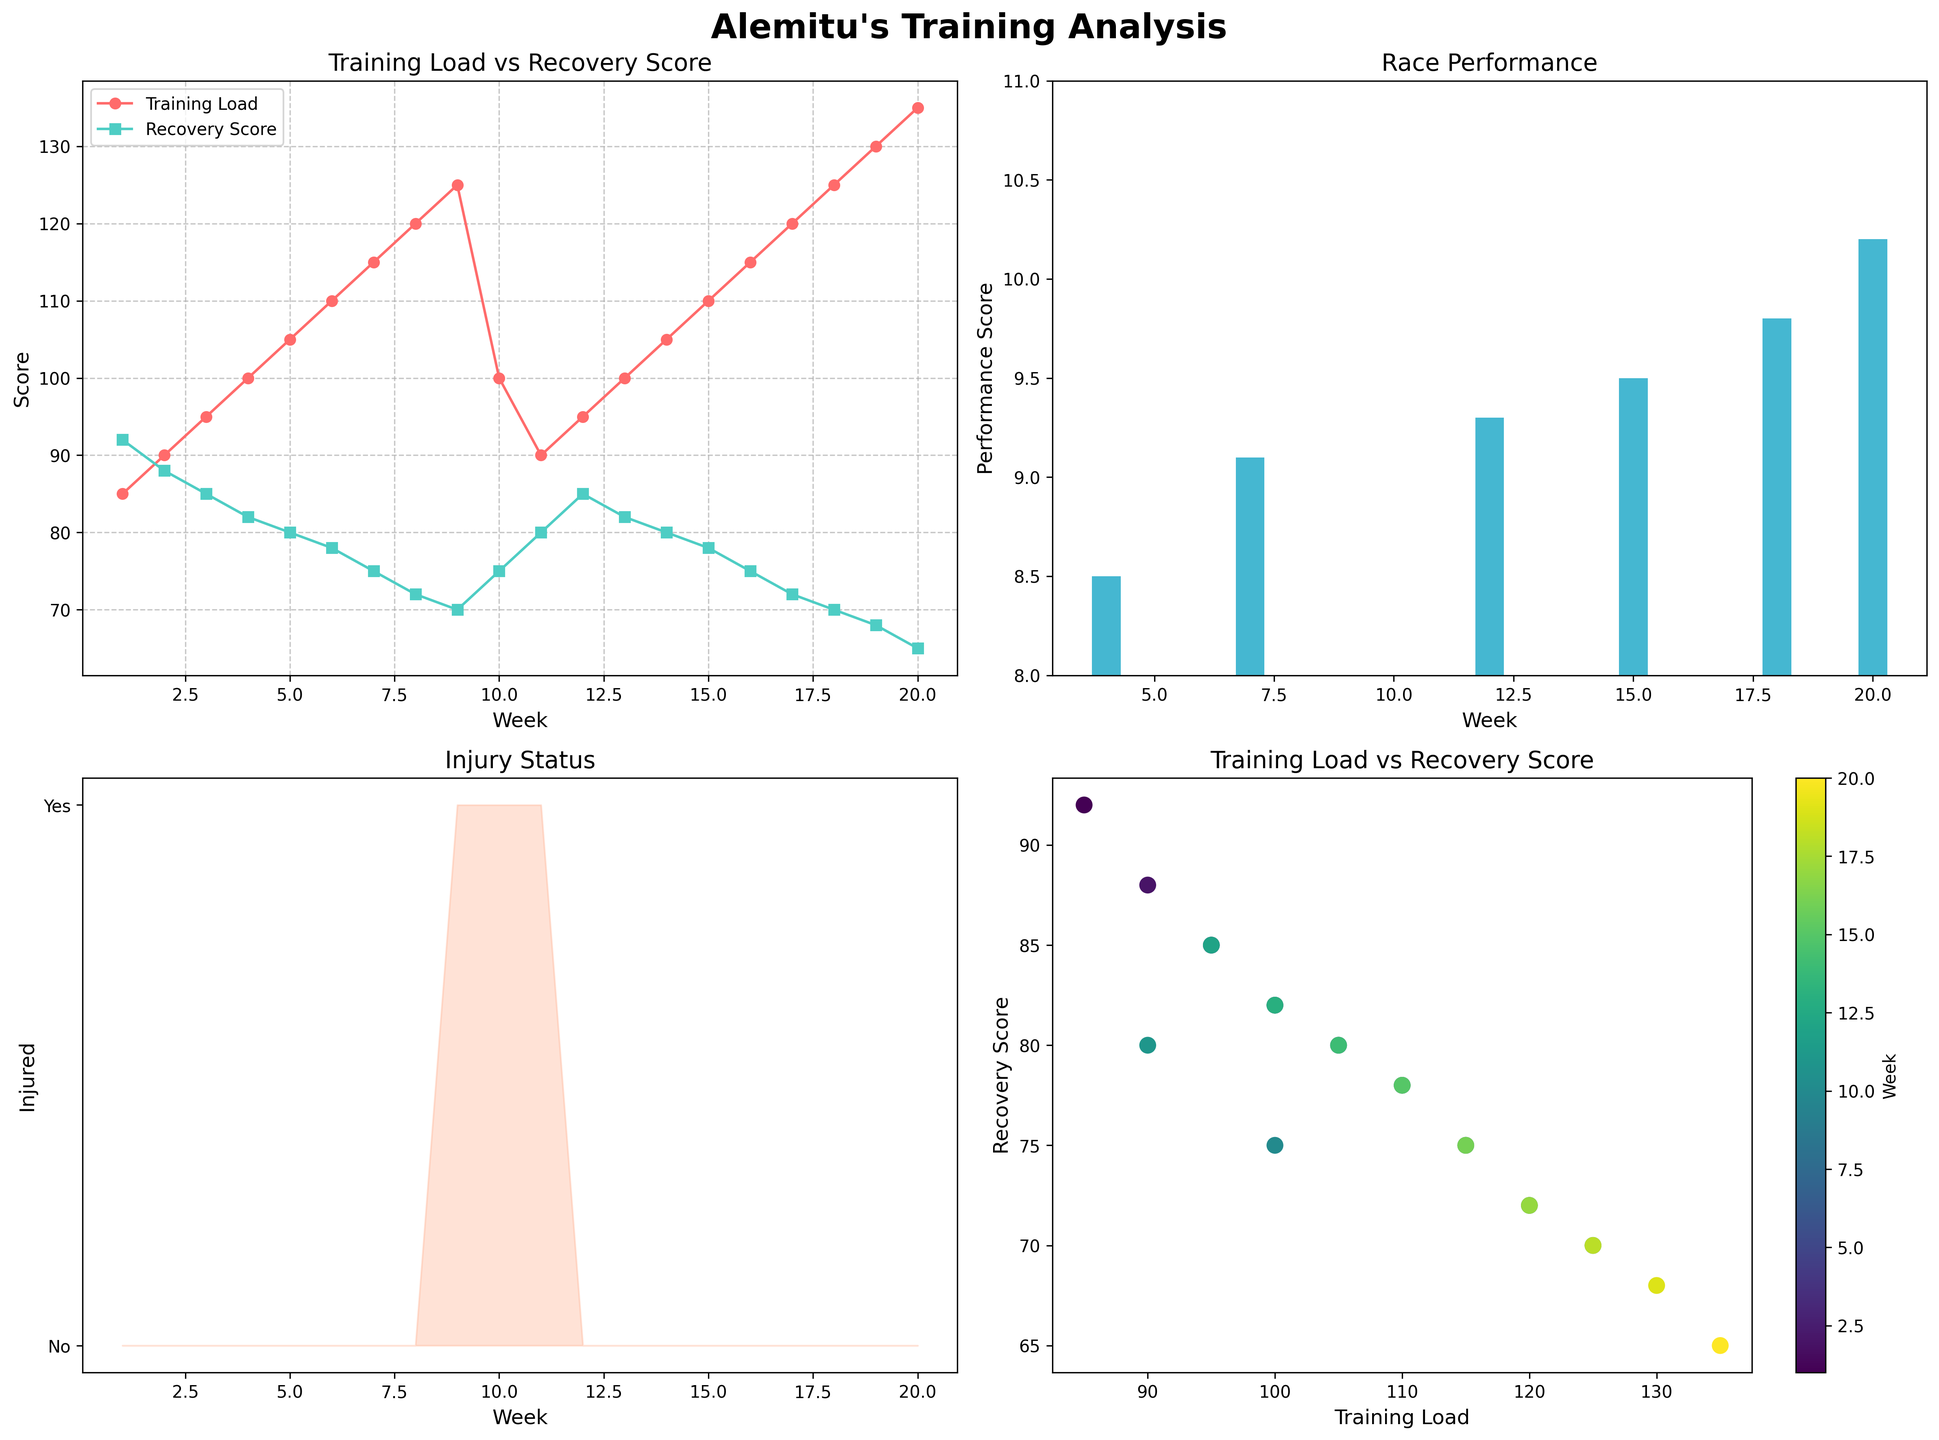What is the title of the entire figure? The title of the entire figure is shown at the top and reads "Alemitu's Training Analysis" in bold and large font.
Answer: Alemitu's Training Analysis Which weeks show a race performance? Race weeks are those where the Race Performance bar is present in the top-right subplot. Weeks 4, 7, 12, 15, 18, and 20 show a race performance.
Answer: Weeks 4, 7, 12, 15, 18, 20 What is the highest race performance shown in the figure, and in which week? To find the highest race performance, look at the top-right bar chart. The highest bar reaches 10.2 in week 20.
Answer: 10.2 in week 20 Did Alemitu have any weeks with an injury status of "Yes"? If so, which weeks? In the bottom-left subplot, areas shaded indicate injury status of "Yes." These are found at weeks 9, 10, and 11.
Answer: Weeks 9, 10, 11 Compare the training load values between weeks 1 and 20? From the top-left plot, the training load in week 1 is 85, and in week 20 it is 135. Comparing them, the training load increased by 50.
Answer: Increased by 50 What trend do you observe between training load and recovery score from week 1 to week 20? The top-left plot shows that as the training load increases from 85 to 135, the recovery score generally decreases from 92 to 65. The trend indicates an inverse relationship.
Answer: Inverse relationship observed How does the overall recovery score correlate with the weeks of injury status shown? The top-left plot shows the recovery score decreases when the training load increases, particularly around the injury weeks 9, 10, and 11, where recovery is lower (70, 75, 80).
Answer: Lower recovery score during injury weeks Identify the color used to indicate training load versus recovery score in the top-left plot. The training load is indicated by a red line, and the recovery score by a teal line in the top-left subplot.
Answer: Red for training load, teal for recovery score In the scatter plot of training load vs. recovery score (bottom-right), what color represents week 20? The color bar next to the scatter plot shows the gradient from light to dark green. Week 20 is represented by a very dark green dot in the scatter plot.
Answer: Dark green What is the average recovery score during weeks when Alemitu had a race performance? From the data, the race performance weeks are 4, 7, 12, 15, 18, and 20. Their recovery scores are 82, 75, 85, 78, 72, and 65, respectively. The average is (82+75+85+78+72+65)/6 = 457/6 ≈ 76.2.
Answer: ≈ 76.2 